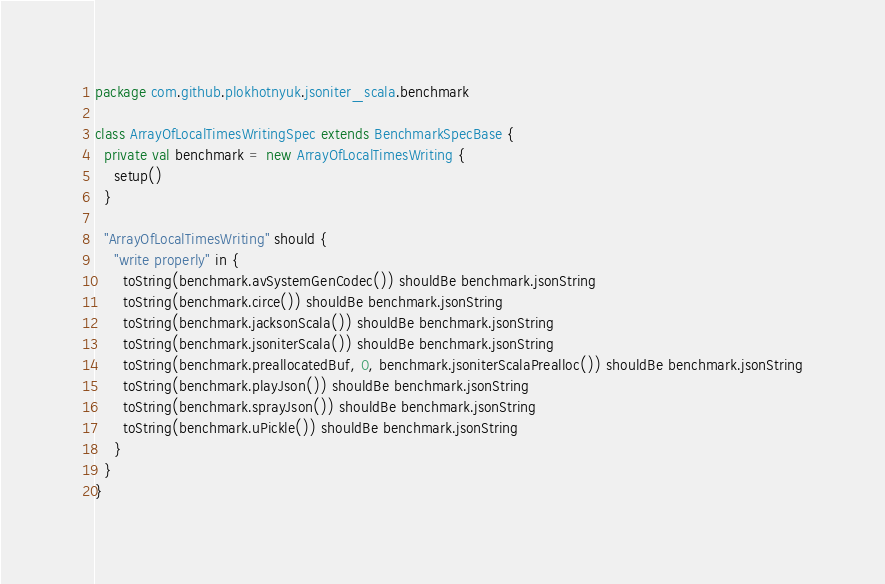Convert code to text. <code><loc_0><loc_0><loc_500><loc_500><_Scala_>package com.github.plokhotnyuk.jsoniter_scala.benchmark

class ArrayOfLocalTimesWritingSpec extends BenchmarkSpecBase {
  private val benchmark = new ArrayOfLocalTimesWriting {
    setup()
  }
  
  "ArrayOfLocalTimesWriting" should {
    "write properly" in {
      toString(benchmark.avSystemGenCodec()) shouldBe benchmark.jsonString
      toString(benchmark.circe()) shouldBe benchmark.jsonString
      toString(benchmark.jacksonScala()) shouldBe benchmark.jsonString
      toString(benchmark.jsoniterScala()) shouldBe benchmark.jsonString
      toString(benchmark.preallocatedBuf, 0, benchmark.jsoniterScalaPrealloc()) shouldBe benchmark.jsonString
      toString(benchmark.playJson()) shouldBe benchmark.jsonString
      toString(benchmark.sprayJson()) shouldBe benchmark.jsonString
      toString(benchmark.uPickle()) shouldBe benchmark.jsonString
    }
  }
}</code> 